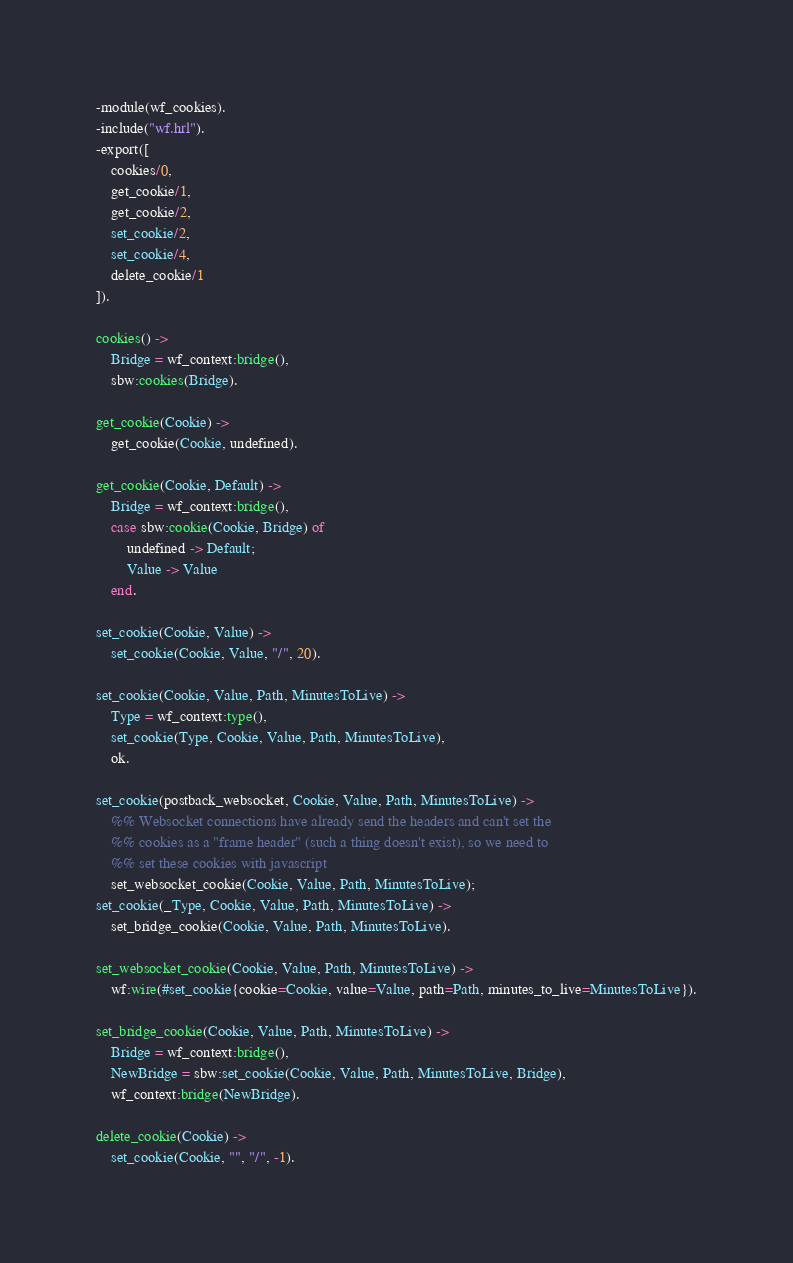<code> <loc_0><loc_0><loc_500><loc_500><_Erlang_>-module(wf_cookies).
-include("wf.hrl").
-export([
	cookies/0,
	get_cookie/1,
	get_cookie/2,
	set_cookie/2,
	set_cookie/4,
	delete_cookie/1
]).

cookies() ->
	Bridge = wf_context:bridge(),
	sbw:cookies(Bridge).

get_cookie(Cookie) ->
	get_cookie(Cookie, undefined).

get_cookie(Cookie, Default) ->
	Bridge = wf_context:bridge(),
	case sbw:cookie(Cookie, Bridge) of
		undefined -> Default;
		Value -> Value
	end.

set_cookie(Cookie, Value) ->
	set_cookie(Cookie, Value, "/", 20).

set_cookie(Cookie, Value, Path, MinutesToLive) ->
	Type = wf_context:type(),
	set_cookie(Type, Cookie, Value, Path, MinutesToLive),
	ok.

set_cookie(postback_websocket, Cookie, Value, Path, MinutesToLive) ->
	%% Websocket connections have already send the headers and can't set the
	%% cookies as a "frame header" (such a thing doesn't exist), so we need to
	%% set these cookies with javascript
	set_websocket_cookie(Cookie, Value, Path, MinutesToLive);
set_cookie(_Type, Cookie, Value, Path, MinutesToLive) ->
	set_bridge_cookie(Cookie, Value, Path, MinutesToLive).

set_websocket_cookie(Cookie, Value, Path, MinutesToLive) ->
	wf:wire(#set_cookie{cookie=Cookie, value=Value, path=Path, minutes_to_live=MinutesToLive}).
	
set_bridge_cookie(Cookie, Value, Path, MinutesToLive) ->
	Bridge = wf_context:bridge(),
	NewBridge = sbw:set_cookie(Cookie, Value, Path, MinutesToLive, Bridge),
	wf_context:bridge(NewBridge).

delete_cookie(Cookie) ->
	set_cookie(Cookie, "", "/", -1).
</code> 